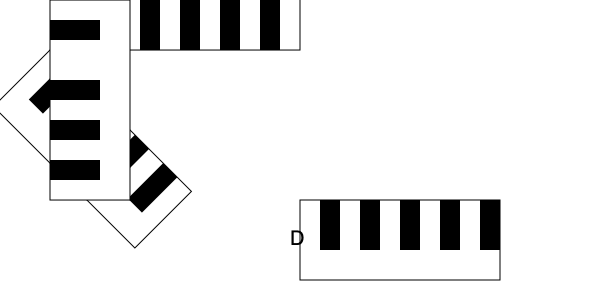Which of the rotated piano key layouts accurately represents the standard arrangement of white and black keys on a piano? To identify the correct piano key layout, let's analyze each option step-by-step:

1. Standard piano key layout:
   - A group of two black keys followed by a group of three black keys
   - This pattern repeats across the keyboard

2. Option A:
   - Rotated 45 degrees clockwise
   - Shows 2 black keys, gap, then 2 black keys
   - Incorrect pattern

3. Option B:
   - Rotated 180 degrees (upside down)
   - Shows 5 evenly spaced black keys
   - Incorrect pattern

4. Option C:
   - Rotated 90 degrees counterclockwise
   - Shows 2 black keys, gap, 1 black key, gap, 1 black key
   - Correct pattern: 2 black keys (group of 2), gap (E-F), 3 black keys (group of 3)

5. Option D:
   - Not rotated (0 degrees)
   - Shows 5 evenly spaced black keys
   - Incorrect pattern

The correct layout is Option C, as it accurately represents the standard arrangement of white and black keys on a piano when rotated back to its original position.
Answer: C 